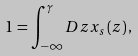<formula> <loc_0><loc_0><loc_500><loc_500>1 = \int _ { - \infty } ^ { \gamma } D z x _ { s } \left ( z \right ) ,</formula> 